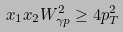<formula> <loc_0><loc_0><loc_500><loc_500>x _ { 1 } x _ { 2 } W _ { \gamma p } ^ { 2 } \geq 4 p _ { T } ^ { 2 }</formula> 